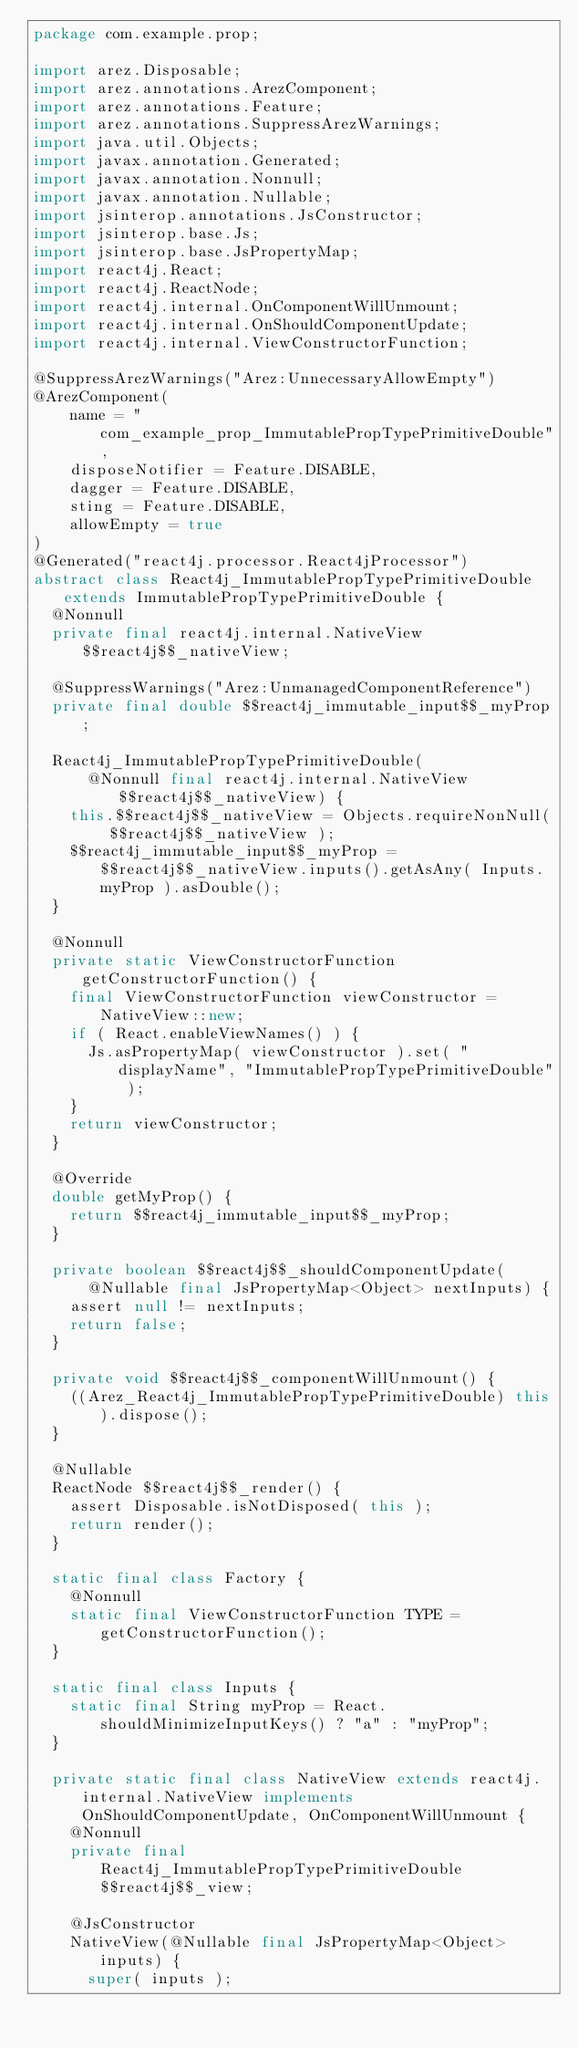<code> <loc_0><loc_0><loc_500><loc_500><_Java_>package com.example.prop;

import arez.Disposable;
import arez.annotations.ArezComponent;
import arez.annotations.Feature;
import arez.annotations.SuppressArezWarnings;
import java.util.Objects;
import javax.annotation.Generated;
import javax.annotation.Nonnull;
import javax.annotation.Nullable;
import jsinterop.annotations.JsConstructor;
import jsinterop.base.Js;
import jsinterop.base.JsPropertyMap;
import react4j.React;
import react4j.ReactNode;
import react4j.internal.OnComponentWillUnmount;
import react4j.internal.OnShouldComponentUpdate;
import react4j.internal.ViewConstructorFunction;

@SuppressArezWarnings("Arez:UnnecessaryAllowEmpty")
@ArezComponent(
    name = "com_example_prop_ImmutablePropTypePrimitiveDouble",
    disposeNotifier = Feature.DISABLE,
    dagger = Feature.DISABLE,
    sting = Feature.DISABLE,
    allowEmpty = true
)
@Generated("react4j.processor.React4jProcessor")
abstract class React4j_ImmutablePropTypePrimitiveDouble extends ImmutablePropTypePrimitiveDouble {
  @Nonnull
  private final react4j.internal.NativeView $$react4j$$_nativeView;

  @SuppressWarnings("Arez:UnmanagedComponentReference")
  private final double $$react4j_immutable_input$$_myProp;

  React4j_ImmutablePropTypePrimitiveDouble(
      @Nonnull final react4j.internal.NativeView $$react4j$$_nativeView) {
    this.$$react4j$$_nativeView = Objects.requireNonNull( $$react4j$$_nativeView );
    $$react4j_immutable_input$$_myProp = $$react4j$$_nativeView.inputs().getAsAny( Inputs.myProp ).asDouble();
  }

  @Nonnull
  private static ViewConstructorFunction getConstructorFunction() {
    final ViewConstructorFunction viewConstructor = NativeView::new;
    if ( React.enableViewNames() ) {
      Js.asPropertyMap( viewConstructor ).set( "displayName", "ImmutablePropTypePrimitiveDouble" );
    }
    return viewConstructor;
  }

  @Override
  double getMyProp() {
    return $$react4j_immutable_input$$_myProp;
  }

  private boolean $$react4j$$_shouldComponentUpdate(
      @Nullable final JsPropertyMap<Object> nextInputs) {
    assert null != nextInputs;
    return false;
  }

  private void $$react4j$$_componentWillUnmount() {
    ((Arez_React4j_ImmutablePropTypePrimitiveDouble) this).dispose();
  }

  @Nullable
  ReactNode $$react4j$$_render() {
    assert Disposable.isNotDisposed( this );
    return render();
  }

  static final class Factory {
    @Nonnull
    static final ViewConstructorFunction TYPE = getConstructorFunction();
  }

  static final class Inputs {
    static final String myProp = React.shouldMinimizeInputKeys() ? "a" : "myProp";
  }

  private static final class NativeView extends react4j.internal.NativeView implements OnShouldComponentUpdate, OnComponentWillUnmount {
    @Nonnull
    private final React4j_ImmutablePropTypePrimitiveDouble $$react4j$$_view;

    @JsConstructor
    NativeView(@Nullable final JsPropertyMap<Object> inputs) {
      super( inputs );</code> 